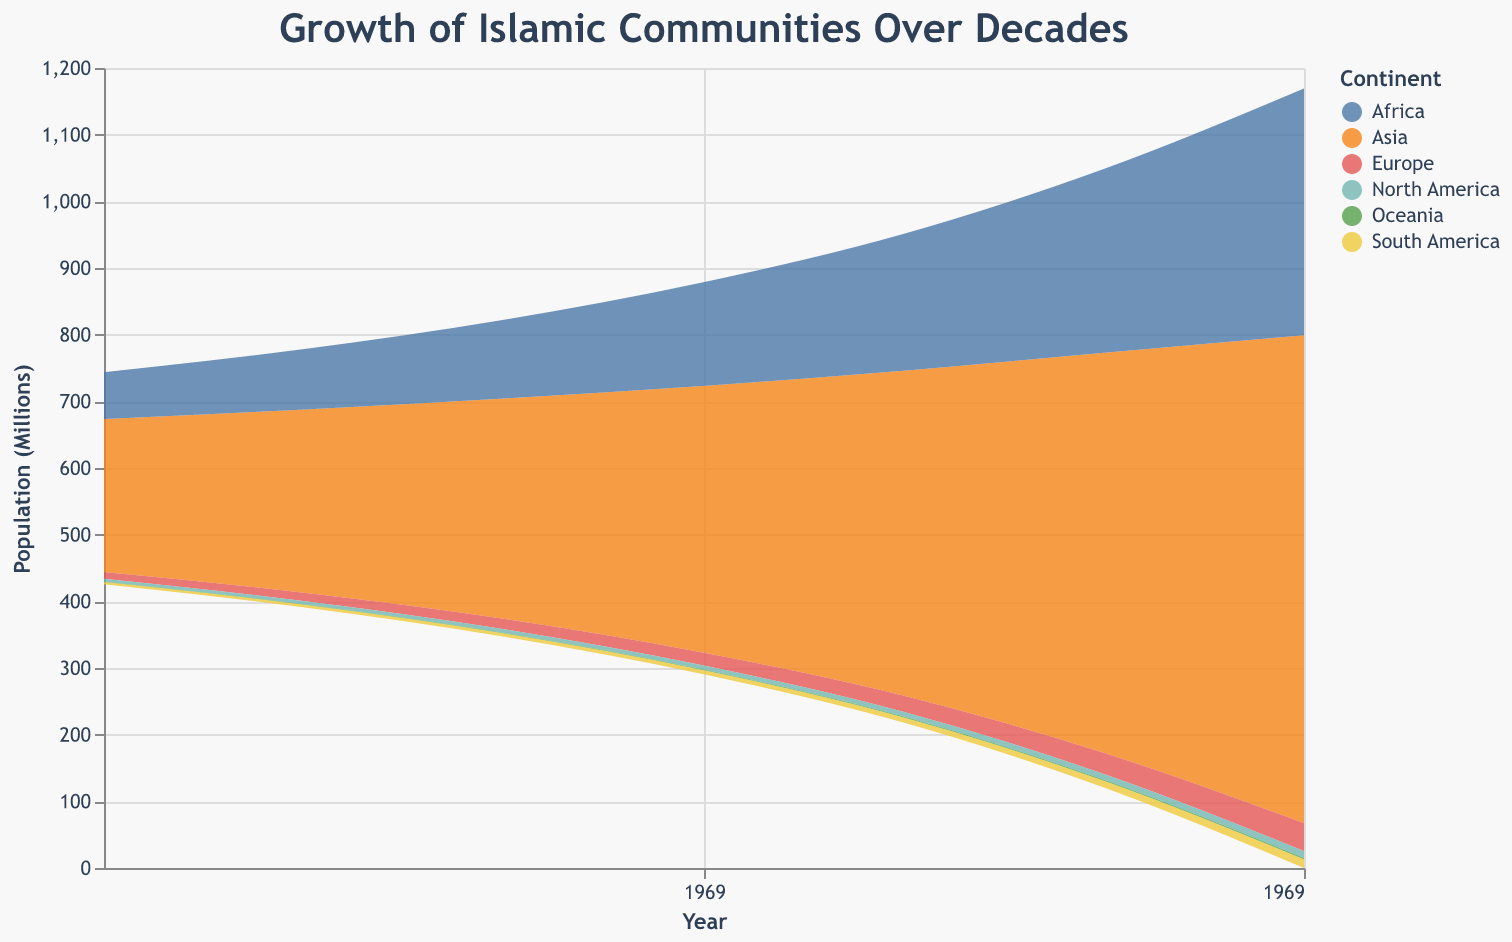What is the title of the figure? The title of the figure is given at the top, it reads "Growth of Islamic Communities Over Decades".
Answer: Growth of Islamic Communities Over Decades Which continent shows the largest population of Islamic communities in 2020? By looking at the colors representing each continent, we observe that Asia has the largest population in 2020.
Answer: Asia In which year did Oceania first reach a population of over 1 million? By examining the growth of the section representing Oceania, it first surpasses 1 million between 1980 and 1990.
Answer: 1990 How did the Islamic population in Africa change between 2000 and 2010? The Islamic population in Africa increased from 205.4 million in 2000 to 275.8 million in 2010.
Answer: Increased by 70.4 million Compare the Islamic populations of North America and South America in 2010. Which had a higher population? From the segments representing North America and South America, we see that South America (10.2 million) had a higher population than North America (8.5 million) in 2010.
Answer: South America What is the total Islamic population across all continents in 1960? Summing the populations of all continents in 1960: 229.5 (Asia) + 70.3 (Africa) + 10.1 (Europe) + 4.2 (North America) + 3.5 (South America) + 0.6 (Oceania) = 318.2 million.
Answer: 318.2 million Which decade saw the largest increase in Islamic population in Asia? By comparing the differences in population for Asia over each decade, the largest increase is between 2010 (600.2 million) and 2020 (731.8 million), an increase of 131.6 million.
Answer: 2010-2020 What is the combined Islamic population in Europe and Oceania in 2020? Adding the populations in Europe (41.9 million) and Oceania (2.0 million) gives a combined population of 43.9 million in 2020.
Answer: 43.9 million Between which years did the Islamic population in Africa see a more than 100 million increase? Observing the increments, the population in Africa grows from 205.4 million in 2000 to 370.2 million in 2020, which is an increase of more than 100 million, first crossing this threshold between 2010 (275.8 million) and 2020 (370.2 million).
Answer: 2000-2020 